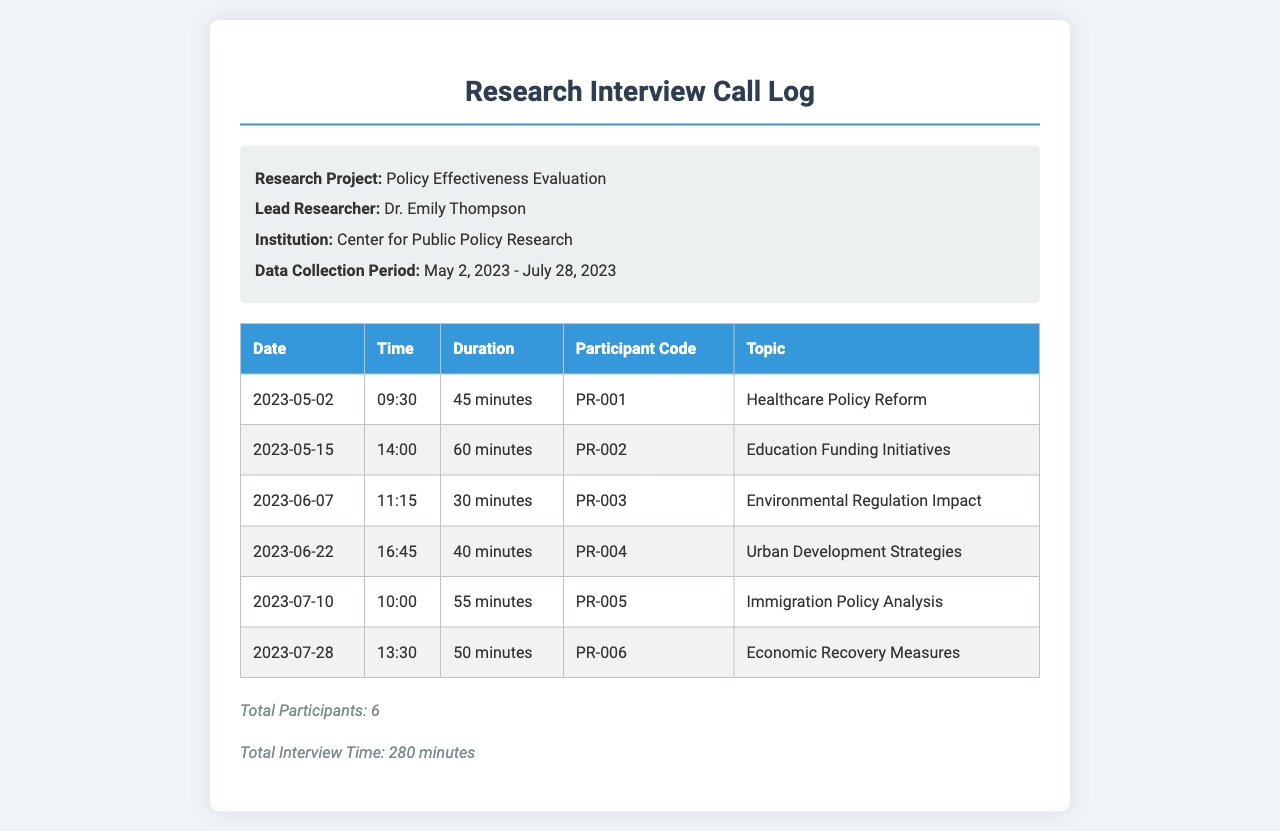What is the research project title? The title of the research project is found in the project info section of the document.
Answer: Policy Effectiveness Evaluation Who is the lead researcher? The name of the lead researcher is stated in the project info section of the document.
Answer: Dr. Emily Thompson What is the total number of participants? The total number of participants can be found in the summary section at the end of the document.
Answer: 6 What was the duration of the interview with participant code PR-004? The duration for participant code PR-004 can be retrieved directly from their entry in the table.
Answer: 40 minutes On what date did the interview regarding Immigration Policy Analysis occur? The date for the Immigration Policy Analysis interview is listed in the table under the specific topic.
Answer: 2023-07-10 What is the total interview time in minutes? The total interview time is summed up in the summary section of the document.
Answer: 280 minutes Which participant code had the longest interview duration? The participant code with the longest duration can be determined by analyzing the durations listed in the table.
Answer: PR-002 At what time did the interview on Environmental Regulation Impact start? The start time for the interview about Environmental Regulation Impact is located in the corresponding table entry.
Answer: 11:15 What was the primary topic of the last interview? The primary topic of the last interview is found in the last row of the table.
Answer: Economic Recovery Measures 